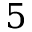<formula> <loc_0><loc_0><loc_500><loc_500>5</formula> 